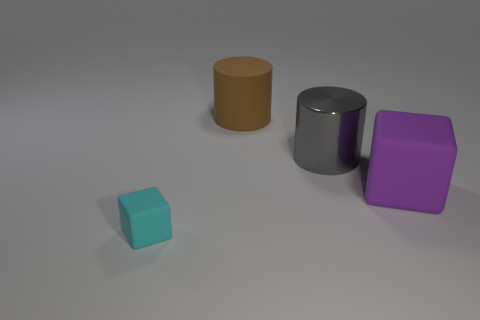Are there any other things that are the same size as the cyan cube?
Ensure brevity in your answer.  No. There is a shiny object that is the same size as the purple cube; what color is it?
Keep it short and to the point. Gray. Does the purple block have the same size as the cyan matte thing?
Make the answer very short. No. There is a matte object that is to the left of the purple rubber cube and in front of the big brown rubber cylinder; what is its size?
Keep it short and to the point. Small. How many metal things are big gray cylinders or gray spheres?
Provide a succinct answer. 1. Are there more things that are behind the purple block than large things?
Make the answer very short. No. There is a block that is on the right side of the cyan block; what is its material?
Your response must be concise. Rubber. How many other tiny objects have the same material as the tiny object?
Keep it short and to the point. 0. There is a object that is to the left of the metal thing and behind the tiny cyan block; what shape is it?
Your answer should be very brief. Cylinder. How many things are either matte objects behind the big purple matte block or metal cylinders that are behind the purple cube?
Give a very brief answer. 2. 